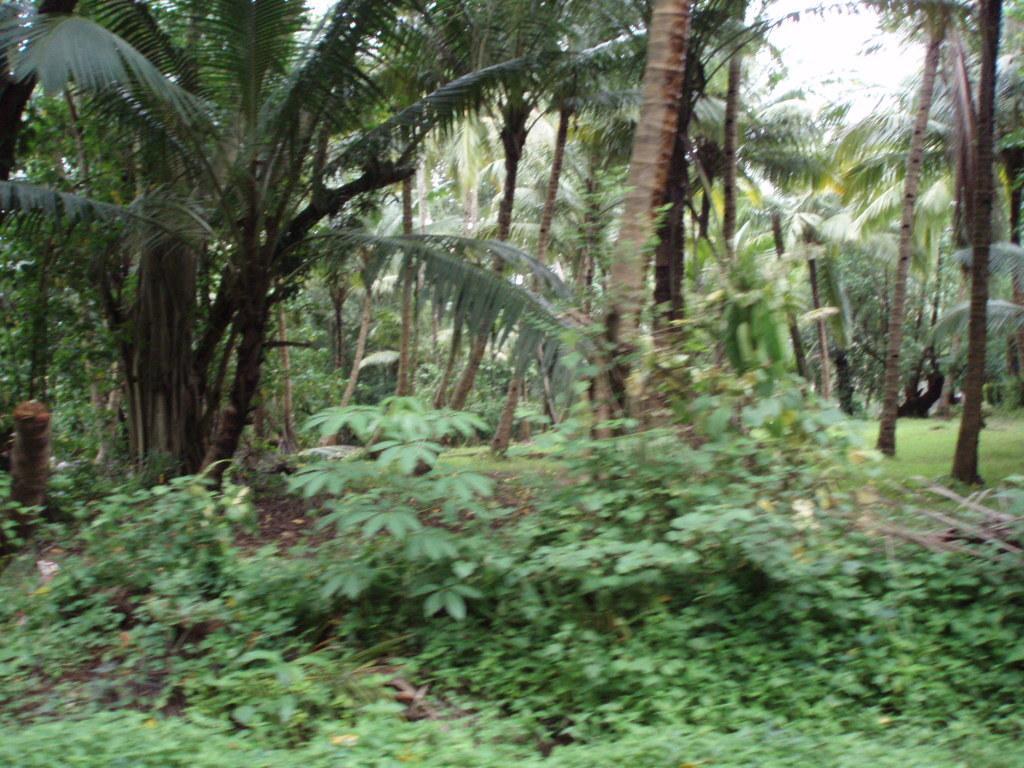Could you give a brief overview of what you see in this image? At the bottom of the picture, there are plants and shrubs. There are trees in the background. This picture is clicked in the garden or in a coconut field. 